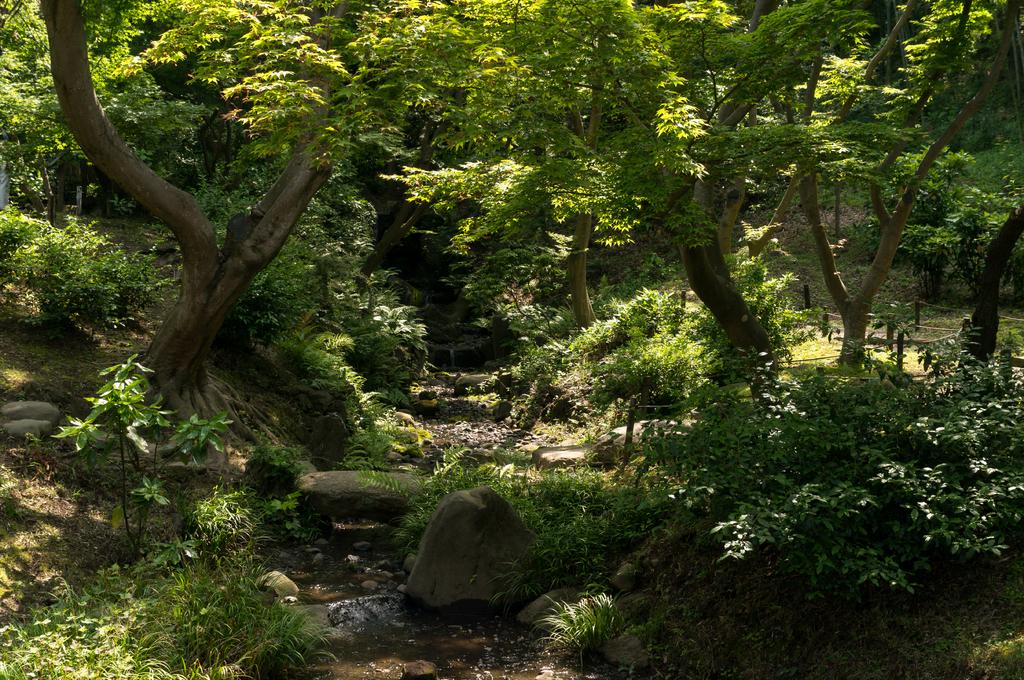What type of environment is depicted in the image? The image appears to have been taken in a forest. What are some of the natural features visible in the image? There are trees and plants in the image. Are there any other geological features present in the image? Yes, there are rocks in the image. What type of potato is being cooked on the stove in the image? There is no potato or stove present in the image; it depicts a forest setting with trees, plants, and rocks. 